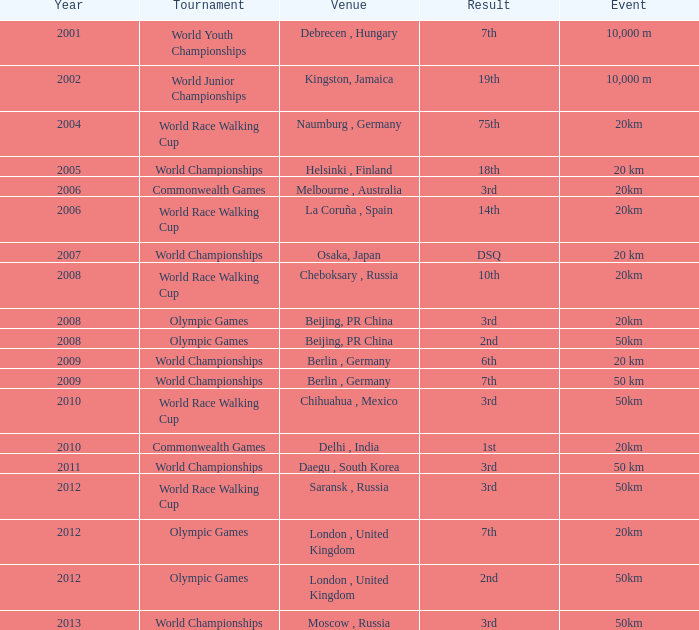What is the result of the World Race Walking Cup tournament played before the year 2010? 3rd. 